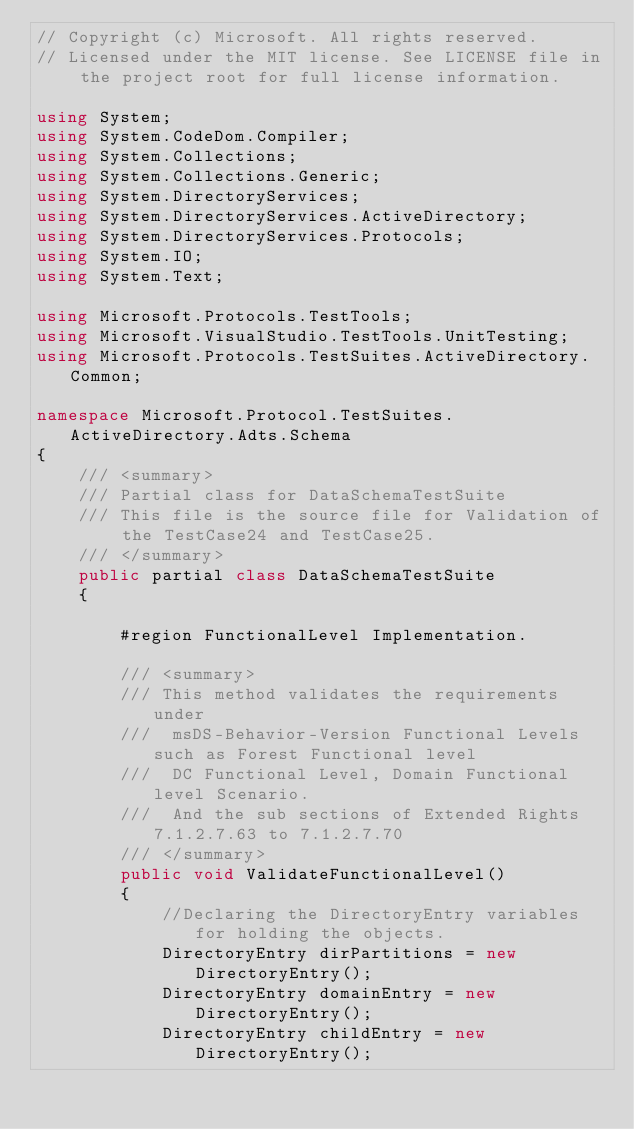Convert code to text. <code><loc_0><loc_0><loc_500><loc_500><_C#_>// Copyright (c) Microsoft. All rights reserved.
// Licensed under the MIT license. See LICENSE file in the project root for full license information.

using System;
using System.CodeDom.Compiler;
using System.Collections;
using System.Collections.Generic;
using System.DirectoryServices;
using System.DirectoryServices.ActiveDirectory;
using System.DirectoryServices.Protocols;
using System.IO;
using System.Text;

using Microsoft.Protocols.TestTools;
using Microsoft.VisualStudio.TestTools.UnitTesting;
using Microsoft.Protocols.TestSuites.ActiveDirectory.Common;

namespace Microsoft.Protocol.TestSuites.ActiveDirectory.Adts.Schema
{
    /// <summary>
    /// Partial class for DataSchemaTestSuite
    /// This file is the source file for Validation of the TestCase24 and TestCase25.
    /// </summary>
    public partial class DataSchemaTestSuite
    {

        #region FunctionalLevel Implementation.

        /// <summary>
        /// This method validates the requirements under 
        ///  msDS-Behavior-Version Functional Levels such as Forest Functional level
        ///  DC Functional Level, Domain Functional level Scenario.
        ///  And the sub sections of Extended Rights 7.1.2.7.63 to 7.1.2.7.70
        /// </summary>  
        public void ValidateFunctionalLevel()
        {
            //Declaring the DirectoryEntry variables for holding the objects.
            DirectoryEntry dirPartitions = new DirectoryEntry();
            DirectoryEntry domainEntry = new DirectoryEntry();
            DirectoryEntry childEntry = new DirectoryEntry();
</code> 